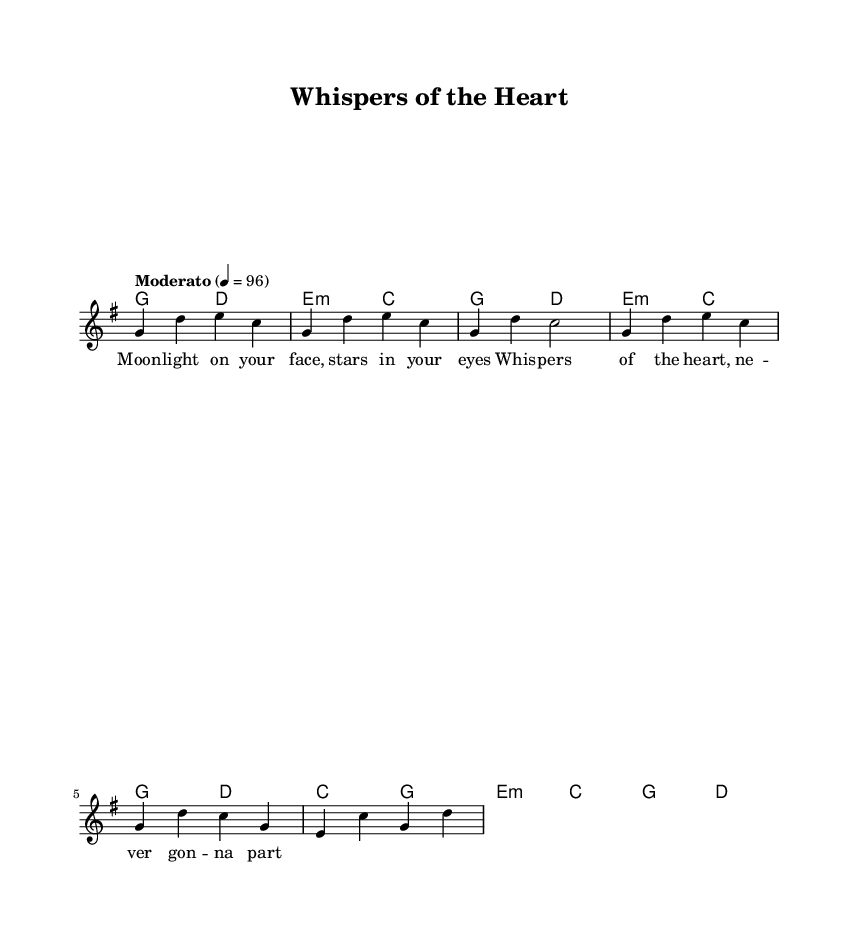What is the key signature of this music? The key signature is G major, which has one sharp (F#).
Answer: G major What is the time signature of this music? The time signature is 4/4, which indicates four beats per measure.
Answer: 4/4 What is the tempo marking of this piece? The tempo marking indicates "Moderato," suggesting a moderate pace.
Answer: Moderato How many measures are in the chorus section? By counting the measures in the section labeled as the chorus, there are four measures present.
Answer: 4 What is the primary theme conveyed in the lyrics? The lyrics, mentioning "Moonlight" and "Whispers of the Heart," suggests a romantic theme focused on love and connection.
Answer: Romantic Which chords mainly accompany the melody throughout the piece? The chords primarily used are G, D, E minor, and C, indicated in the harmonies section.
Answer: G, D, E minor, C Explain the structure of the song given in the sheet music. The structure includes an intro, followed by a verse and a chorus, indicating a typical verse-chorus form often found in romantic duets. The song also includes a partial bridge.
Answer: Intro, Verse, Chorus, Bridge 